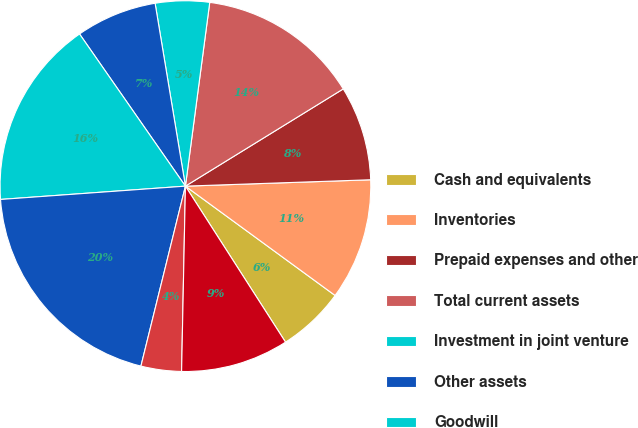Convert chart to OTSL. <chart><loc_0><loc_0><loc_500><loc_500><pie_chart><fcel>Cash and equivalents<fcel>Inventories<fcel>Prepaid expenses and other<fcel>Total current assets<fcel>Investment in joint venture<fcel>Other assets<fcel>Goodwill<fcel>Total assets<fcel>Notes payable and current<fcel>Trade accounts payable<nl><fcel>5.88%<fcel>10.59%<fcel>8.24%<fcel>14.12%<fcel>4.71%<fcel>7.06%<fcel>16.47%<fcel>20.0%<fcel>3.53%<fcel>9.41%<nl></chart> 